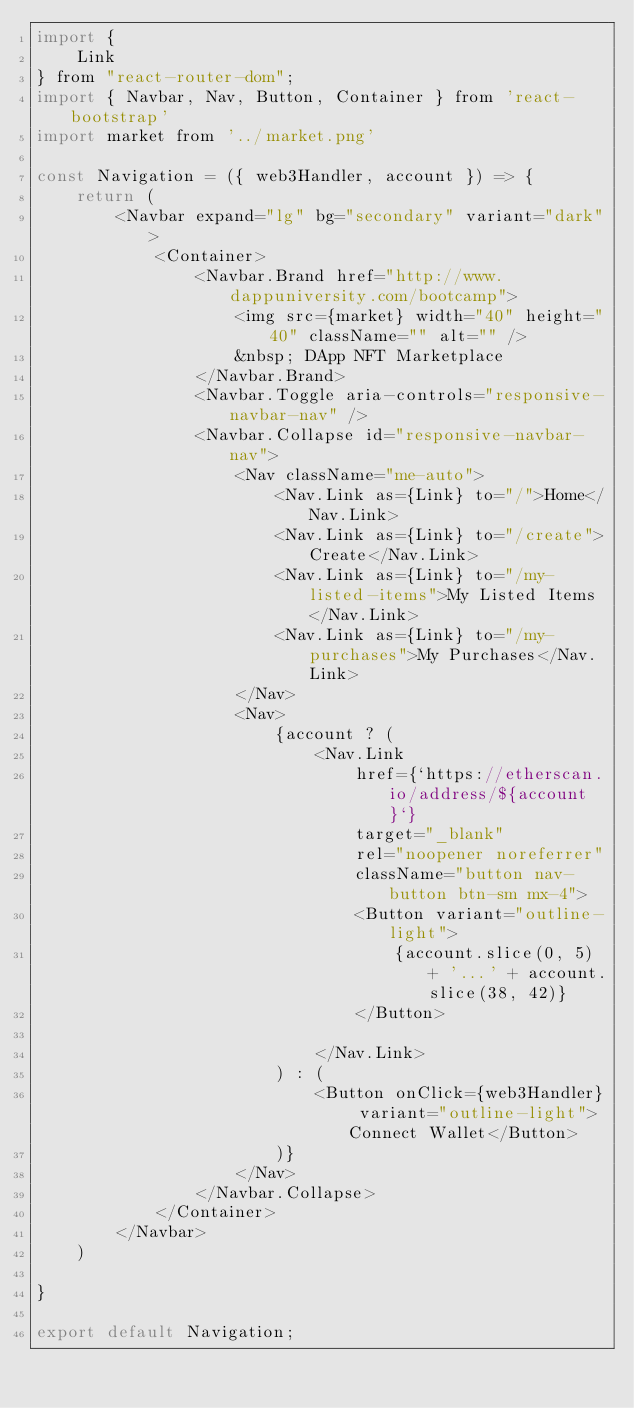<code> <loc_0><loc_0><loc_500><loc_500><_JavaScript_>import {
    Link
} from "react-router-dom";
import { Navbar, Nav, Button, Container } from 'react-bootstrap'
import market from '../market.png'

const Navigation = ({ web3Handler, account }) => {
    return (
        <Navbar expand="lg" bg="secondary" variant="dark">
            <Container>
                <Navbar.Brand href="http://www.dappuniversity.com/bootcamp">
                    <img src={market} width="40" height="40" className="" alt="" />
                    &nbsp; DApp NFT Marketplace
                </Navbar.Brand>
                <Navbar.Toggle aria-controls="responsive-navbar-nav" />
                <Navbar.Collapse id="responsive-navbar-nav">
                    <Nav className="me-auto">
                        <Nav.Link as={Link} to="/">Home</Nav.Link>
                        <Nav.Link as={Link} to="/create">Create</Nav.Link>
                        <Nav.Link as={Link} to="/my-listed-items">My Listed Items</Nav.Link>
                        <Nav.Link as={Link} to="/my-purchases">My Purchases</Nav.Link>
                    </Nav>
                    <Nav>
                        {account ? (
                            <Nav.Link
                                href={`https://etherscan.io/address/${account}`}
                                target="_blank"
                                rel="noopener noreferrer"
                                className="button nav-button btn-sm mx-4">
                                <Button variant="outline-light">
                                    {account.slice(0, 5) + '...' + account.slice(38, 42)}
                                </Button>

                            </Nav.Link>
                        ) : (
                            <Button onClick={web3Handler} variant="outline-light">Connect Wallet</Button>
                        )}
                    </Nav>
                </Navbar.Collapse>
            </Container>
        </Navbar>
    )

}

export default Navigation;
</code> 